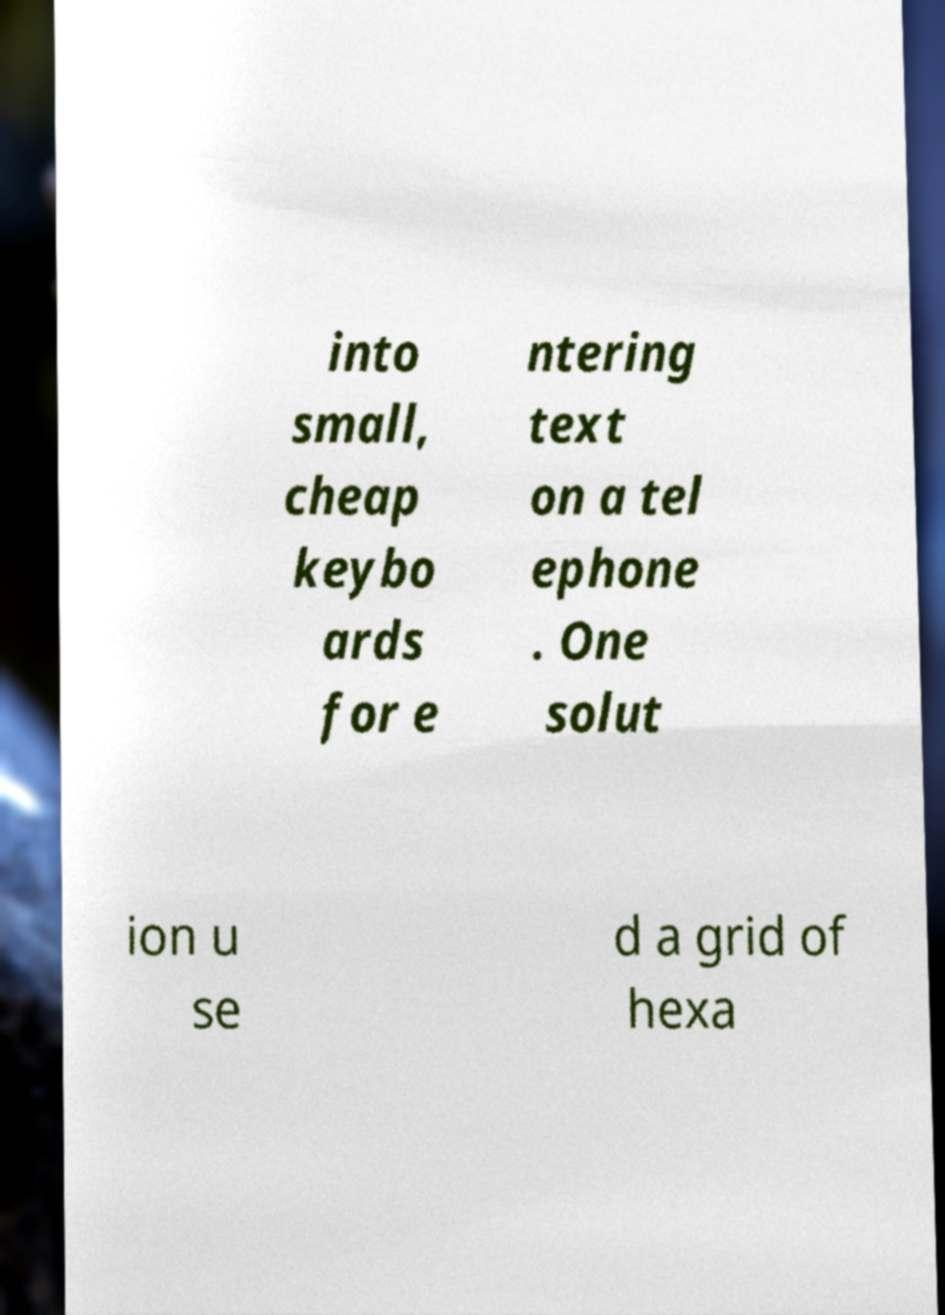For documentation purposes, I need the text within this image transcribed. Could you provide that? into small, cheap keybo ards for e ntering text on a tel ephone . One solut ion u se d a grid of hexa 